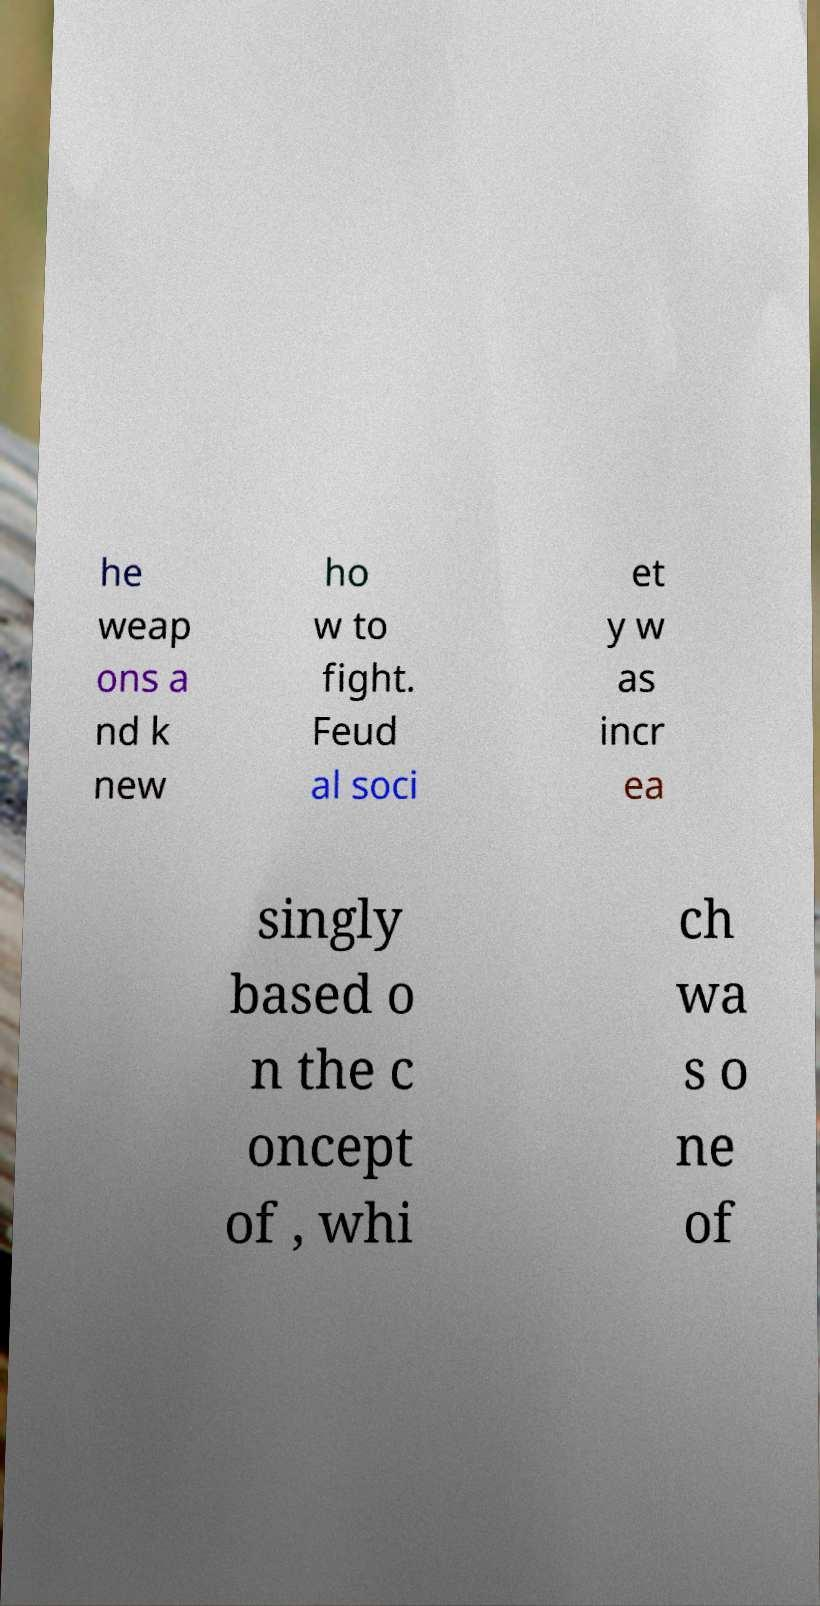For documentation purposes, I need the text within this image transcribed. Could you provide that? he weap ons a nd k new ho w to fight. Feud al soci et y w as incr ea singly based o n the c oncept of , whi ch wa s o ne of 